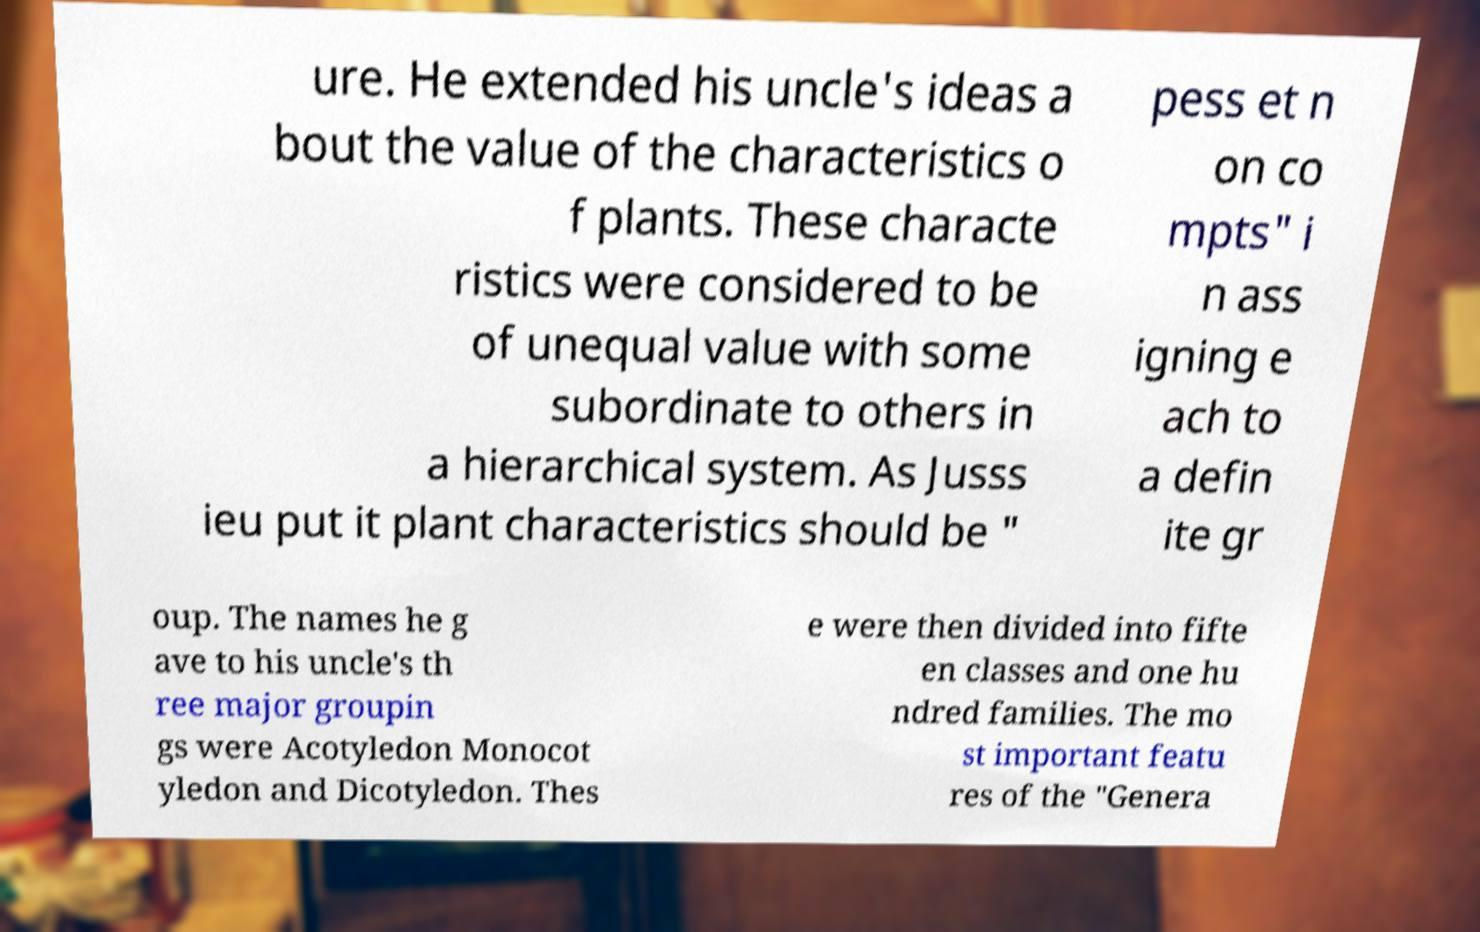There's text embedded in this image that I need extracted. Can you transcribe it verbatim? ure. He extended his uncle's ideas a bout the value of the characteristics o f plants. These characte ristics were considered to be of unequal value with some subordinate to others in a hierarchical system. As Jusss ieu put it plant characteristics should be " pess et n on co mpts" i n ass igning e ach to a defin ite gr oup. The names he g ave to his uncle's th ree major groupin gs were Acotyledon Monocot yledon and Dicotyledon. Thes e were then divided into fifte en classes and one hu ndred families. The mo st important featu res of the "Genera 